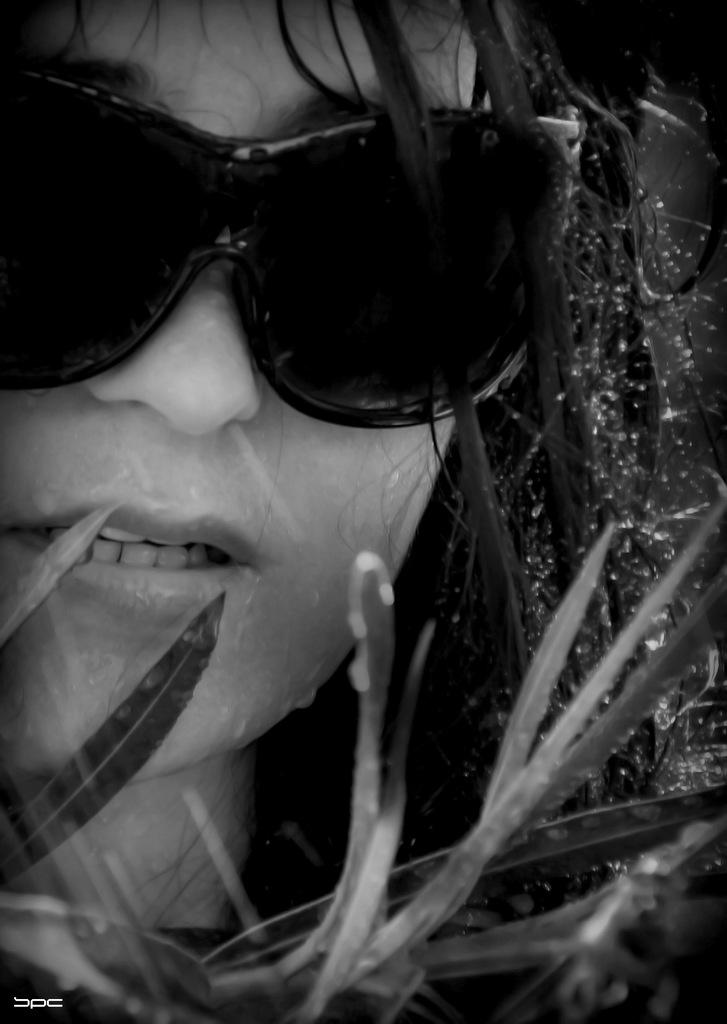Who is the main subject in the image? There is a girl in the image. What is the girl wearing in the image? The girl is wearing spectacles in the image. What else can be seen in the image besides the girl? Leaves of a plant are visible in the image. What invention is the girl credited for in the image? There is no invention or credit mentioned in the image; it simply shows a girl wearing spectacles and surrounded by plant leaves. 